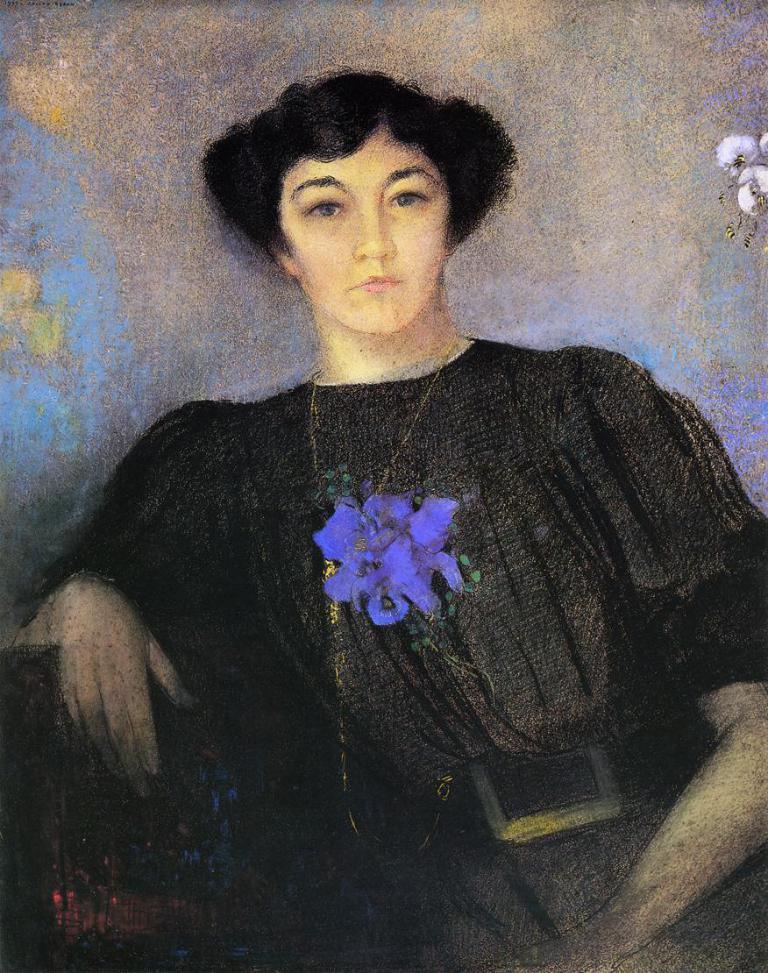How would you summarize this image in a sentence or two? In this image there is an art of a person and art of birds on the wall. 